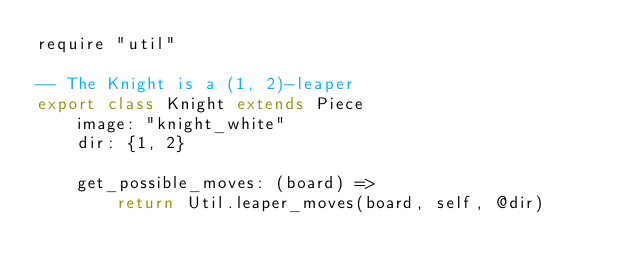<code> <loc_0><loc_0><loc_500><loc_500><_MoonScript_>require "util"

-- The Knight is a (1, 2)-leaper
export class Knight extends Piece
    image: "knight_white"
    dir: {1, 2}

    get_possible_moves: (board) =>
        return Util.leaper_moves(board, self, @dir)
</code> 